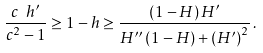<formula> <loc_0><loc_0><loc_500><loc_500>\frac { c \ h ^ { \prime } } { c ^ { 2 } - 1 } \geq 1 - h \geq \frac { \left ( 1 - H \right ) H ^ { \prime } } { H ^ { \prime \prime } \left ( 1 - H \right ) + \left ( H ^ { \prime } \right ) ^ { 2 } } \, .</formula> 